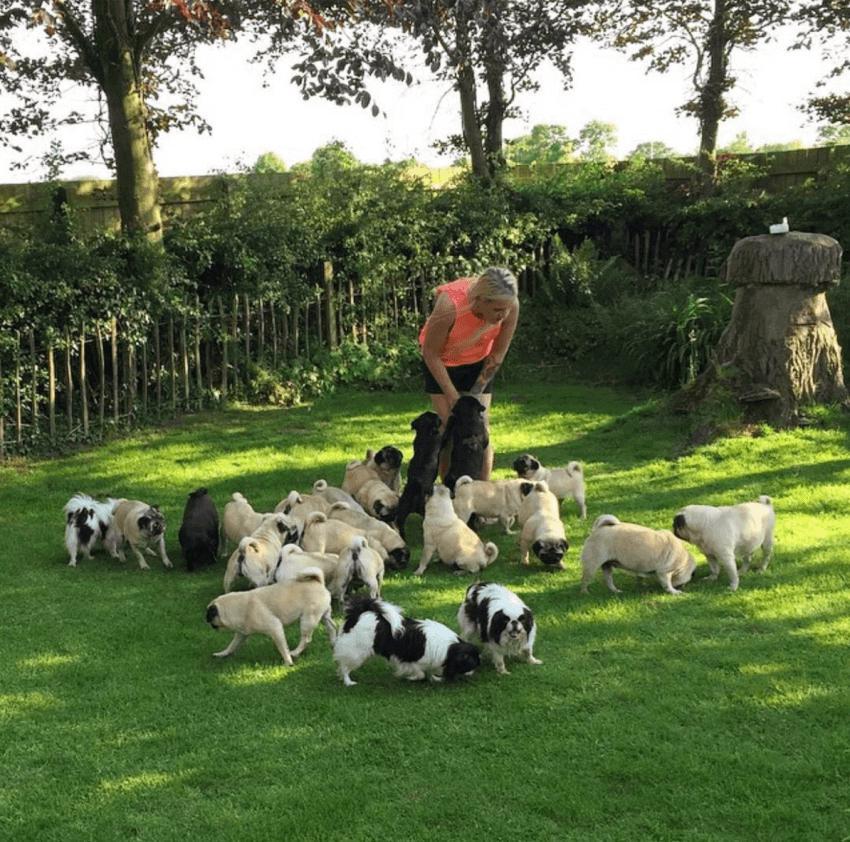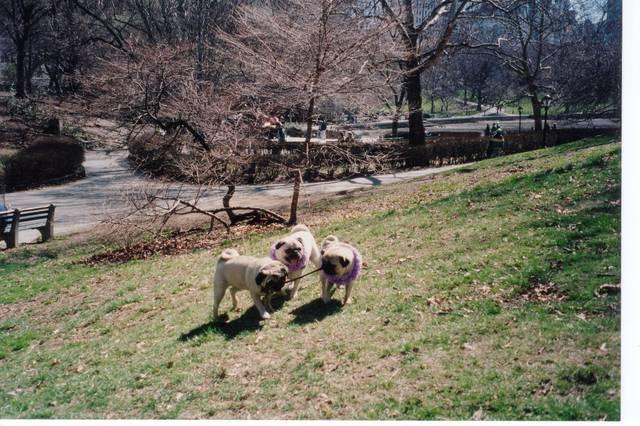The first image is the image on the left, the second image is the image on the right. Examine the images to the left and right. Is the description "A person is standing in one of the images." accurate? Answer yes or no. Yes. 